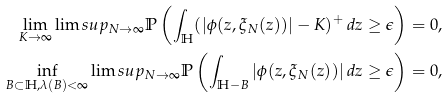<formula> <loc_0><loc_0><loc_500><loc_500>\lim _ { K \to \infty } \lim s u p _ { N \to \infty } \mathbb { P } \left ( \int _ { \mathbb { H } } ( | \phi ( z , \xi _ { N } ( z ) ) | - K ) ^ { + } \, d z \geq \epsilon \right ) & = 0 , \\ \inf _ { B \subset \mathbb { H } , \lambda ( B ) < \infty } \lim s u p _ { N \to \infty } \mathbb { P } \left ( \int _ { \mathbb { H } - B } | \phi ( z , \xi _ { N } ( z ) ) | \, d z \geq \epsilon \right ) & = 0 ,</formula> 